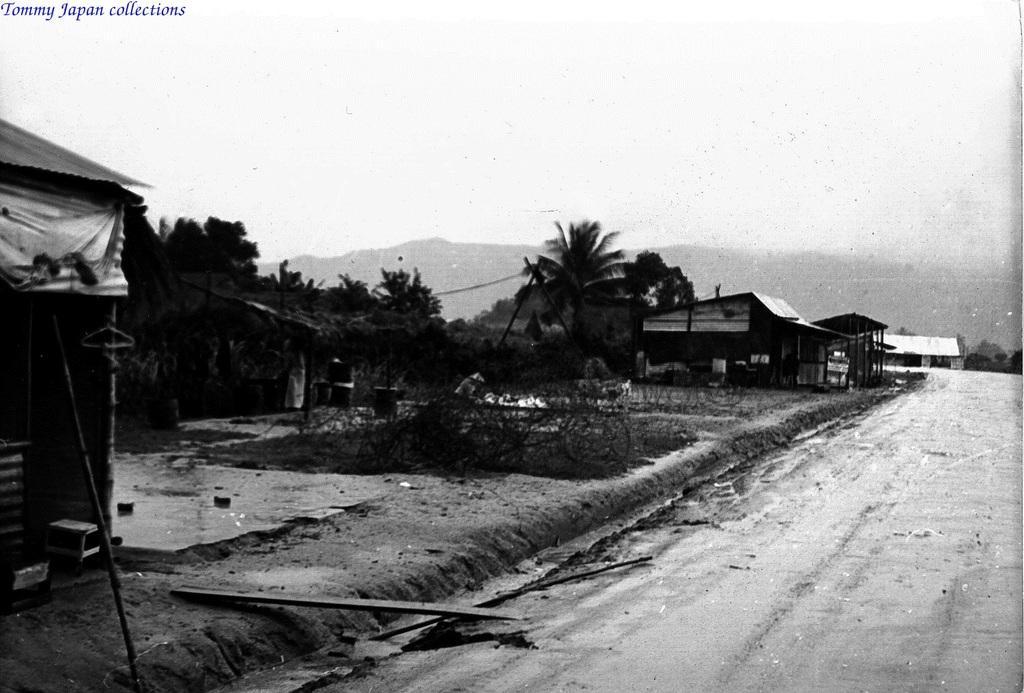How would you summarize this image in a sentence or two? In this black and white image there are houses, in front of the houses there are trees and a road. In the background there are mountains and the sky. On the bottom right side there is some text. 